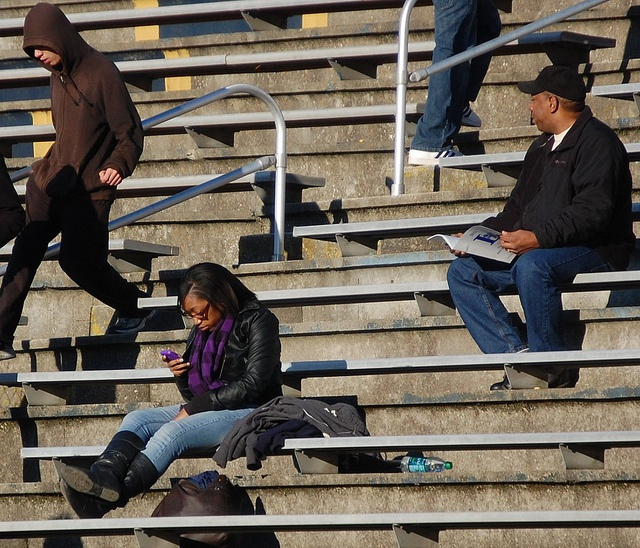Describe the objects in this image and their specific colors. I can see people in gray, black, navy, darkblue, and darkgray tones, people in gray, black, and maroon tones, people in gray, black, and darkgray tones, people in gray, black, blue, and navy tones, and handbag in gray, black, and navy tones in this image. 